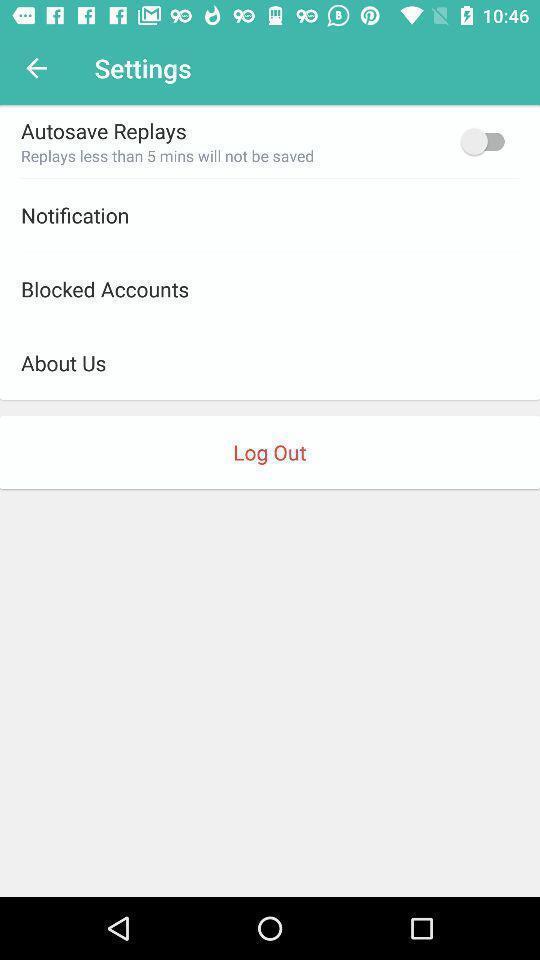Tell me about the visual elements in this screen capture. Settings page. 